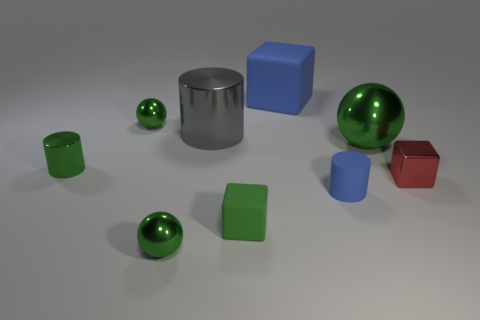The object that is to the right of the blue cube and in front of the metallic block has what shape?
Give a very brief answer. Cylinder. Are there any balls that have the same color as the large metal cylinder?
Give a very brief answer. No. What color is the tiny block that is right of the big metal thing right of the tiny green cube?
Keep it short and to the point. Red. There is a green sphere that is on the right side of the rubber object behind the small green shiny ball that is behind the large metallic sphere; what is its size?
Your response must be concise. Large. Do the red block and the tiny green object that is behind the big gray cylinder have the same material?
Give a very brief answer. Yes. There is a blue block that is made of the same material as the tiny blue cylinder; what size is it?
Provide a short and direct response. Large. Are there any cyan things that have the same shape as the green matte thing?
Provide a short and direct response. No. What number of things are either rubber things that are in front of the big green object or purple rubber balls?
Make the answer very short. 2. There is a block that is the same color as the small rubber cylinder; what is its size?
Provide a short and direct response. Large. Is the color of the matte thing that is behind the large shiny cylinder the same as the cylinder in front of the green metal cylinder?
Your answer should be compact. Yes. 